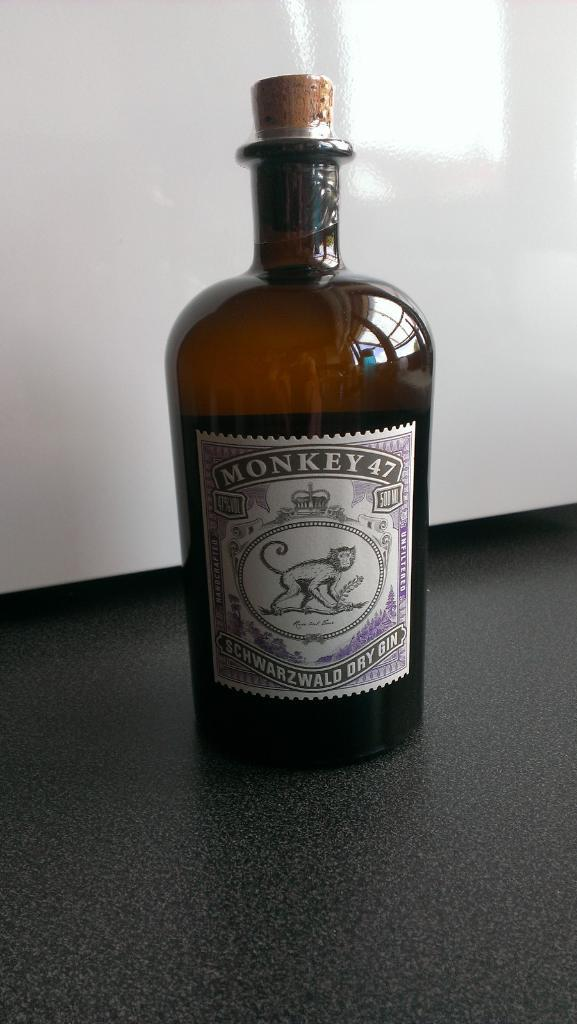<image>
Present a compact description of the photo's key features. A bottle of Monkey 47 brand gin with a cork. 